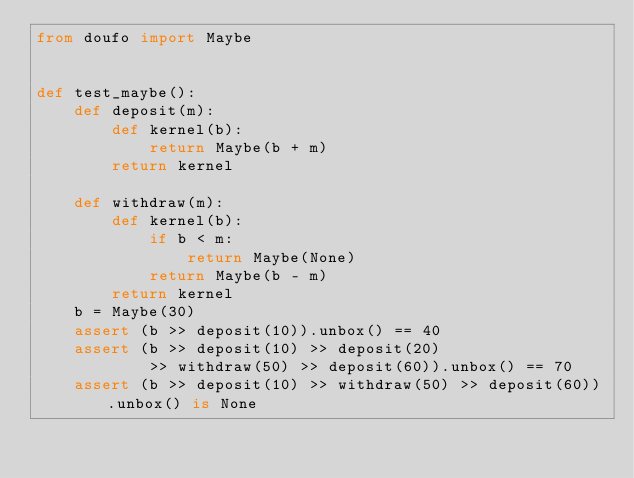<code> <loc_0><loc_0><loc_500><loc_500><_Python_>from doufo import Maybe


def test_maybe():
    def deposit(m):
        def kernel(b):
            return Maybe(b + m)
        return kernel

    def withdraw(m):
        def kernel(b):
            if b < m:
                return Maybe(None)
            return Maybe(b - m)
        return kernel
    b = Maybe(30)
    assert (b >> deposit(10)).unbox() == 40
    assert (b >> deposit(10) >> deposit(20)
            >> withdraw(50) >> deposit(60)).unbox() == 70
    assert (b >> deposit(10) >> withdraw(50) >> deposit(60)).unbox() is None
</code> 